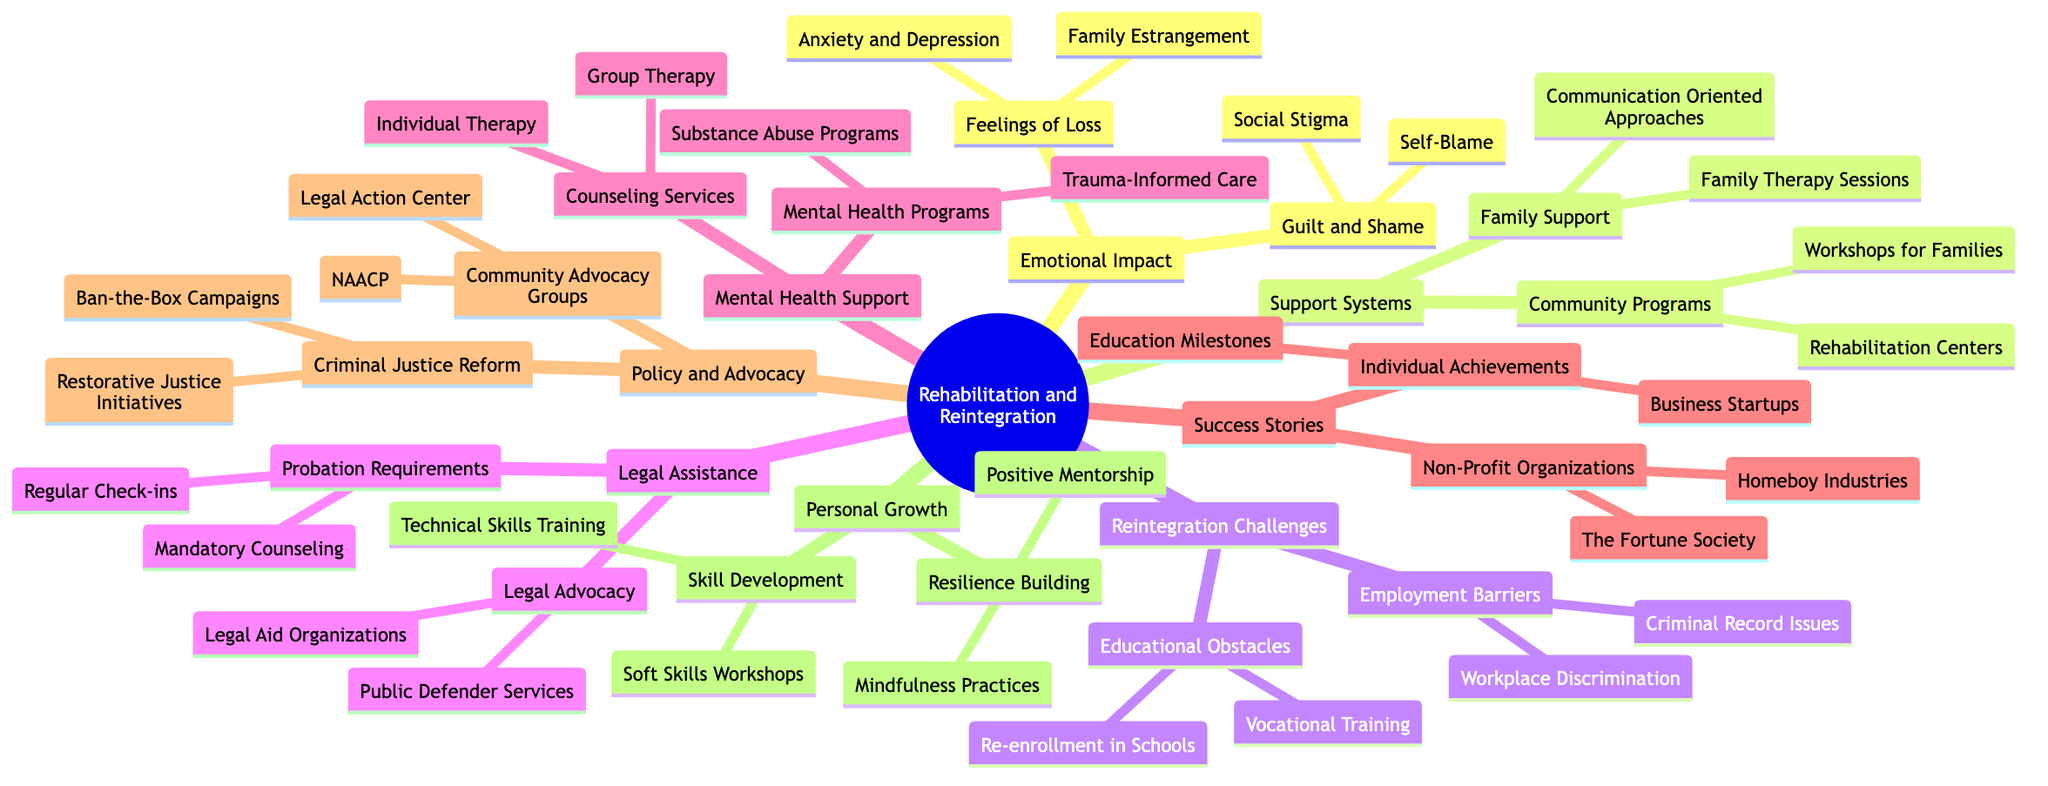What are the two main emotional impacts outlined in the diagram? The diagram lists "Emotional Impact" as a main category, with two subcategories: "Feelings of Loss" and "Guilt and Shame."
Answer: Feelings of Loss, Guilt and Shame How many success stories are illustrated in the mind map? The "Success Stories" section has two main branches: "Non-Profit Organizations" and "Individual Achievements," which indicates there are two types of success stories identified.
Answer: 2 What is one of the barriers to employment mentioned in the diagram? Under the "Reintegration Challenges," the section identifies "Employment Barriers," and lists "Criminal Record Issues." This specifies one of the challenges faced during reintegration.
Answer: Criminal Record Issues Which support system includes family therapy sessions? The "Support Systems" category has the branch "Family Support," which specifically includes "Family Therapy Sessions." This indicates where family therapy fits into the support structure.
Answer: Family Support What type of programs are mentioned under Mental Health Support? The "Mental Health Support" section includes different types of programs, specifically mentioning "Substance Abuse Programs" and "Trauma-Informed Care," indicating the kind of mental health initiatives available.
Answer: Substance Abuse Programs, Trauma-Informed Care Which organization is listed as a non-profit success story? In the "Success Stories" section, "The Fortune Society" is identified as one of the non-profit organizations demonstrating successful rehabilitation and reintegration efforts.
Answer: The Fortune Society What legal assistance requirement involves regular check-ins? Under "Legal Assistance," the "Probation Requirements" subcategory lists "Regular Check-ins" as a certain requirement that individuals may face after incarceration.
Answer: Regular Check-ins What is one focus of the Personal Growth section? The "Personal Growth" section consists of "Skill Development" and "Resilience Building," indicating the main areas aimed at fostering individual improvement after reintegration.
Answer: Skill Development, Resilience Building How does the diagram define Community Advocacy Groups? Under the "Policy and Advocacy" main branch, "Community Advocacy Groups" include organizations like "NAACP" and "Legal Action Center," showcasing types of advocacy efforts available for communities.
Answer: NAACP, Legal Action Center 